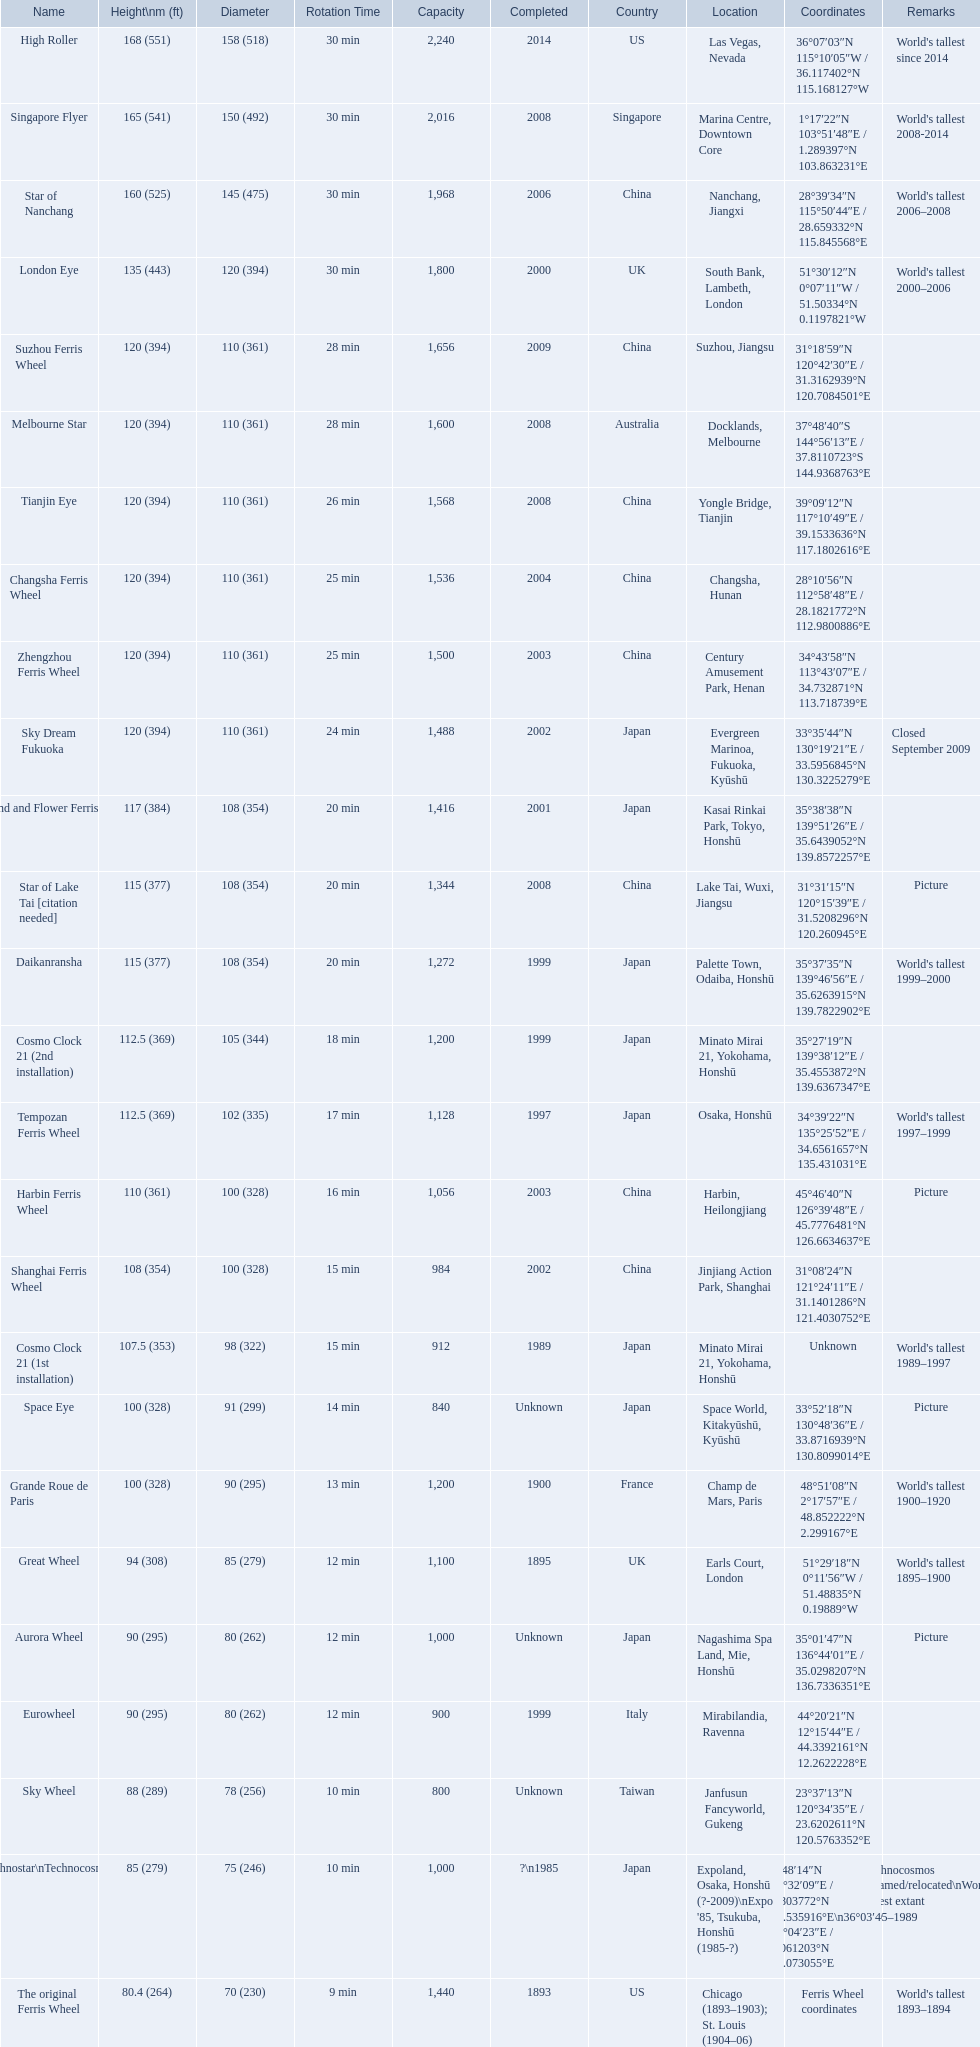What are the different completion dates for the ferris wheel list? 2014, 2008, 2006, 2000, 2009, 2008, 2008, 2004, 2003, 2002, 2001, 2008, 1999, 1999, 1997, 2003, 2002, 1989, Unknown, 1900, 1895, Unknown, 1999, Unknown, ?\n1985, 1893. Which dates for the star of lake tai, star of nanchang, melbourne star? 2006, 2008, 2008. Which is the oldest? 2006. What ride name is this for? Star of Nanchang. 